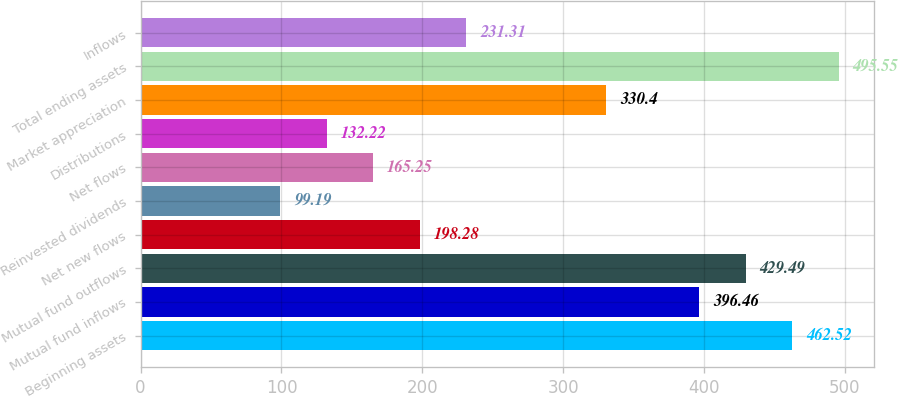<chart> <loc_0><loc_0><loc_500><loc_500><bar_chart><fcel>Beginning assets<fcel>Mutual fund inflows<fcel>Mutual fund outflows<fcel>Net new flows<fcel>Reinvested dividends<fcel>Net flows<fcel>Distributions<fcel>Market appreciation<fcel>Total ending assets<fcel>Inflows<nl><fcel>462.52<fcel>396.46<fcel>429.49<fcel>198.28<fcel>99.19<fcel>165.25<fcel>132.22<fcel>330.4<fcel>495.55<fcel>231.31<nl></chart> 